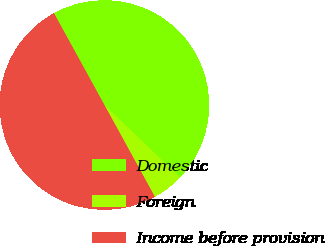<chart> <loc_0><loc_0><loc_500><loc_500><pie_chart><fcel>Domestic<fcel>Foreign<fcel>Income before provision<nl><fcel>45.15%<fcel>4.85%<fcel>50.0%<nl></chart> 